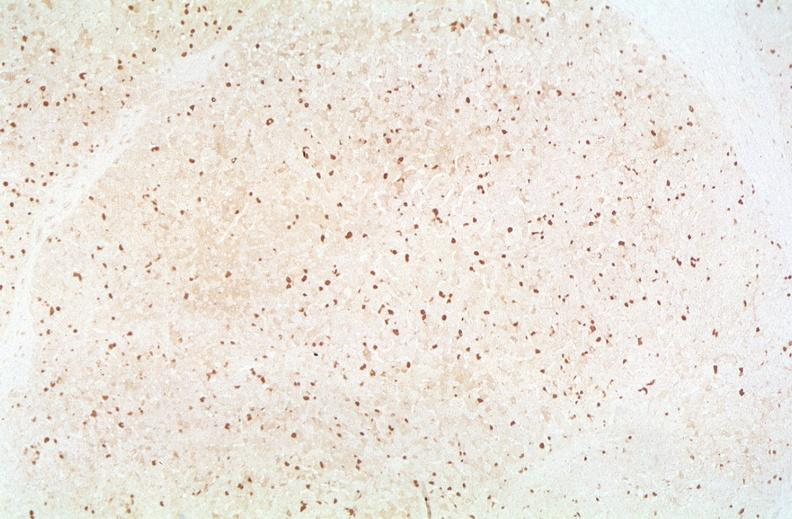what is present?
Answer the question using a single word or phrase. Hepatobiliary 